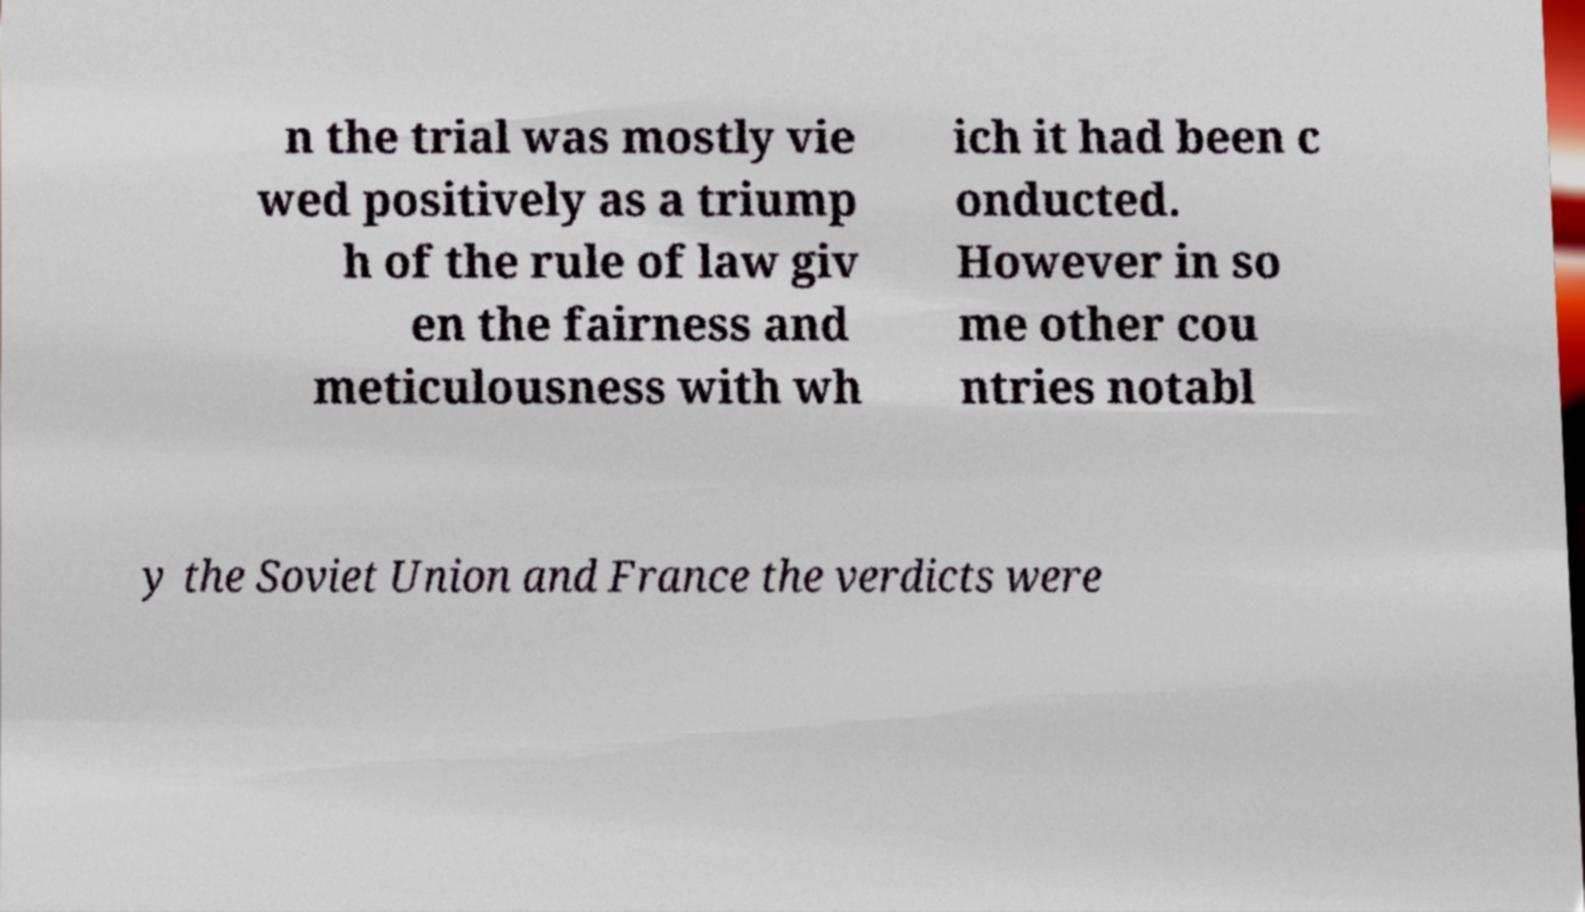There's text embedded in this image that I need extracted. Can you transcribe it verbatim? n the trial was mostly vie wed positively as a triump h of the rule of law giv en the fairness and meticulousness with wh ich it had been c onducted. However in so me other cou ntries notabl y the Soviet Union and France the verdicts were 